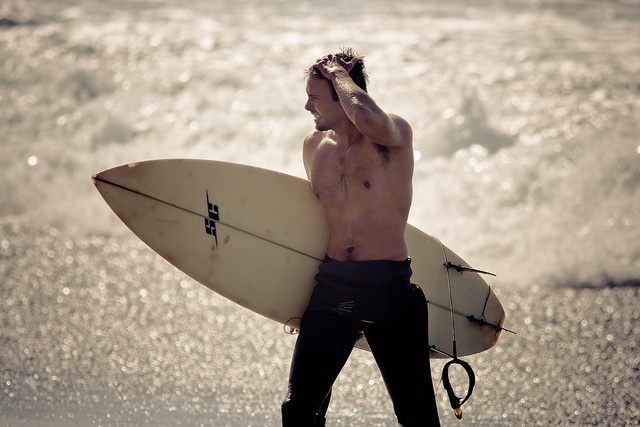Describe the objects in this image and their specific colors. I can see people in gray, black, brown, and maroon tones and surfboard in gray, maroon, and black tones in this image. 